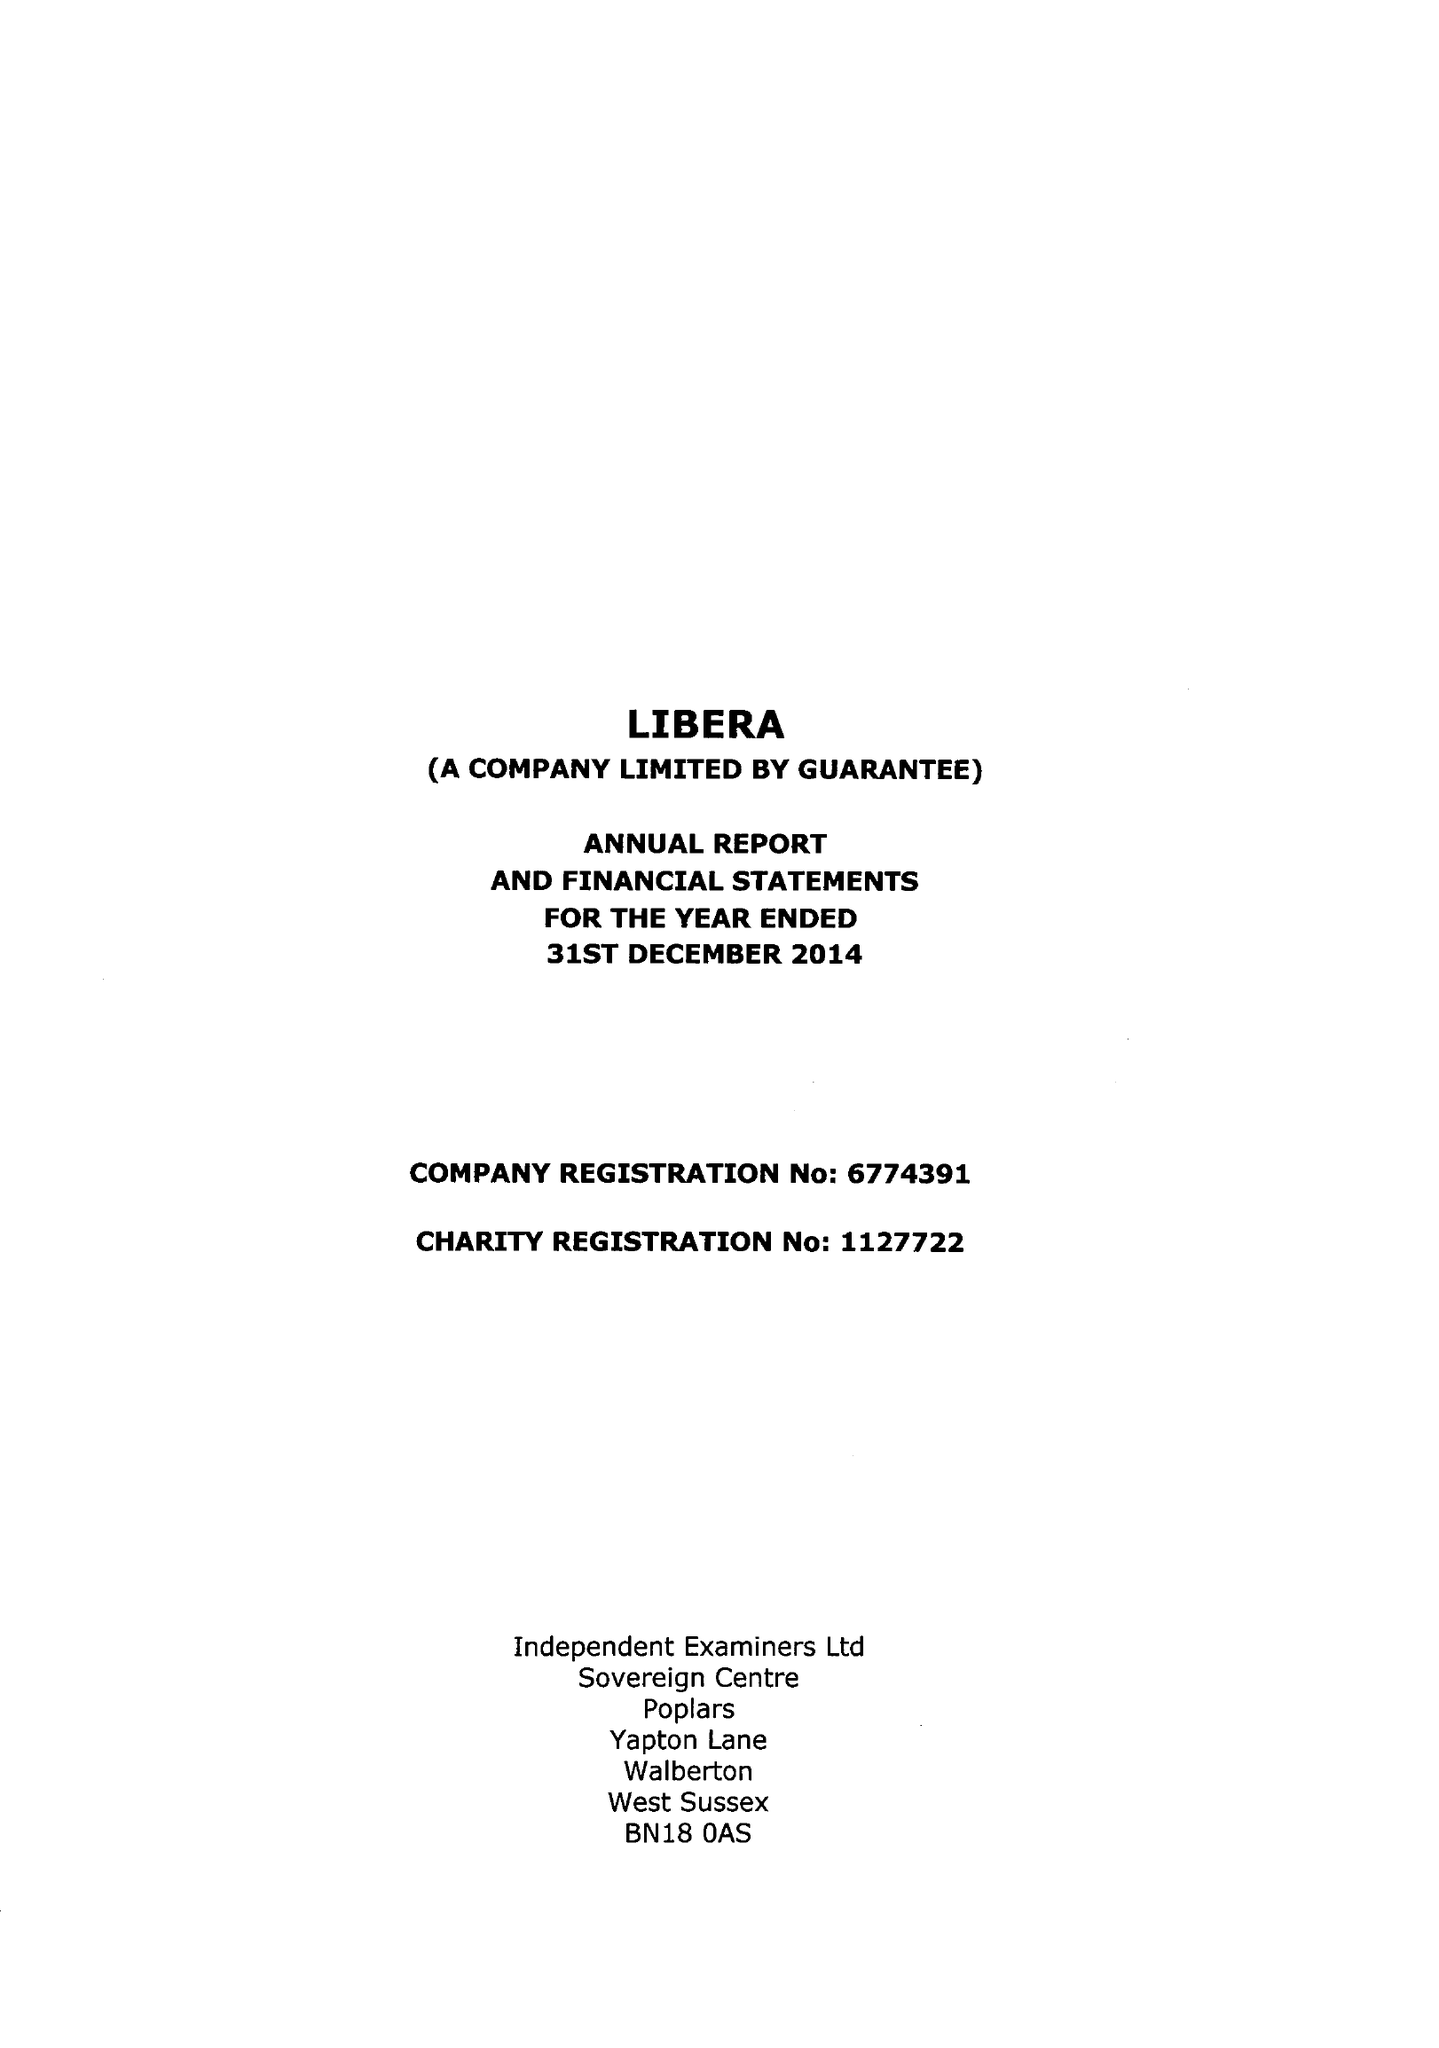What is the value for the spending_annually_in_british_pounds?
Answer the question using a single word or phrase. 50511.00 